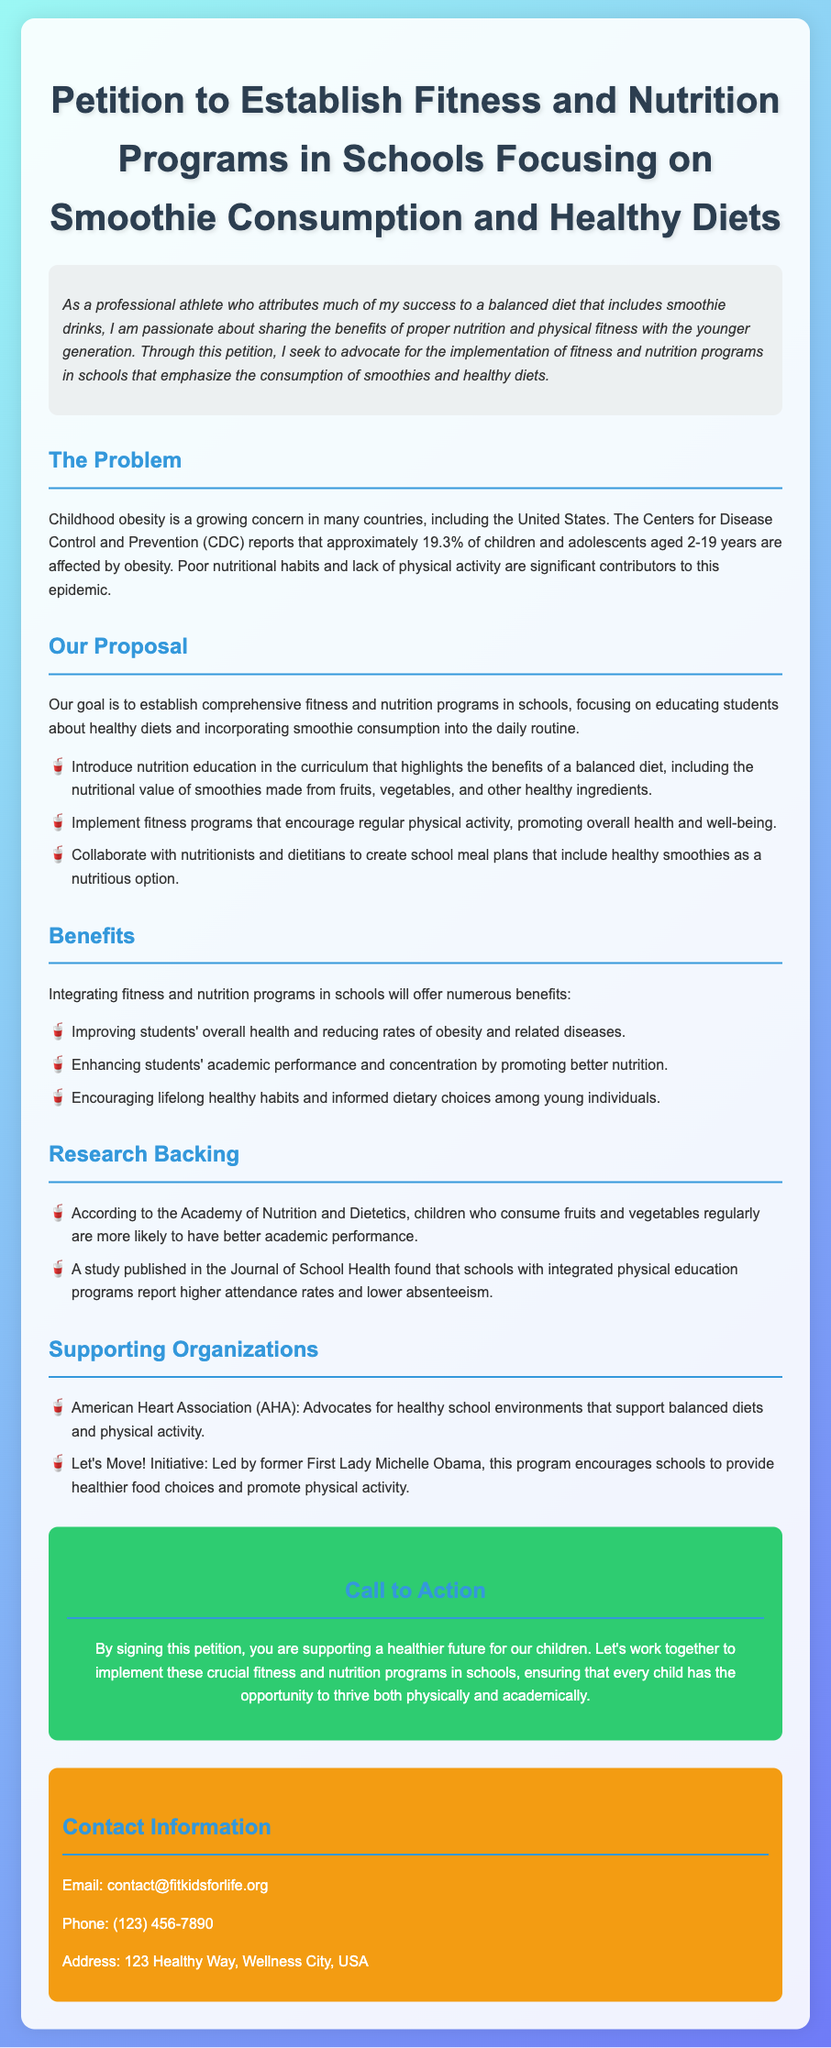What is the title of the petition? The title provides the main subject of the document, which is clearly stated at the beginning.
Answer: Petition to Establish Fitness and Nutrition Programs in Schools Focusing on Smoothie Consumption and Healthy Diets What percentage of children aged 2-19 years are affected by obesity according to the CDC? The document states a specific percentage mentioning the obesity epidemic among children.
Answer: 19.3% What organization led the Let's Move! Initiative? This question asks for the name of the individual associated with a supporting organization mentioned in the document.
Answer: Michelle Obama What is one proposed benefit of integrating fitness and nutrition programs in schools? Several benefits are listed in the document; this question asks for a summary of one of those benefits.
Answer: Improving students' overall health What type of educational program is being proposed in schools concerning smoothies? This aims to find out the specific educational aspect mentioned in the proposal.
Answer: Nutrition education 